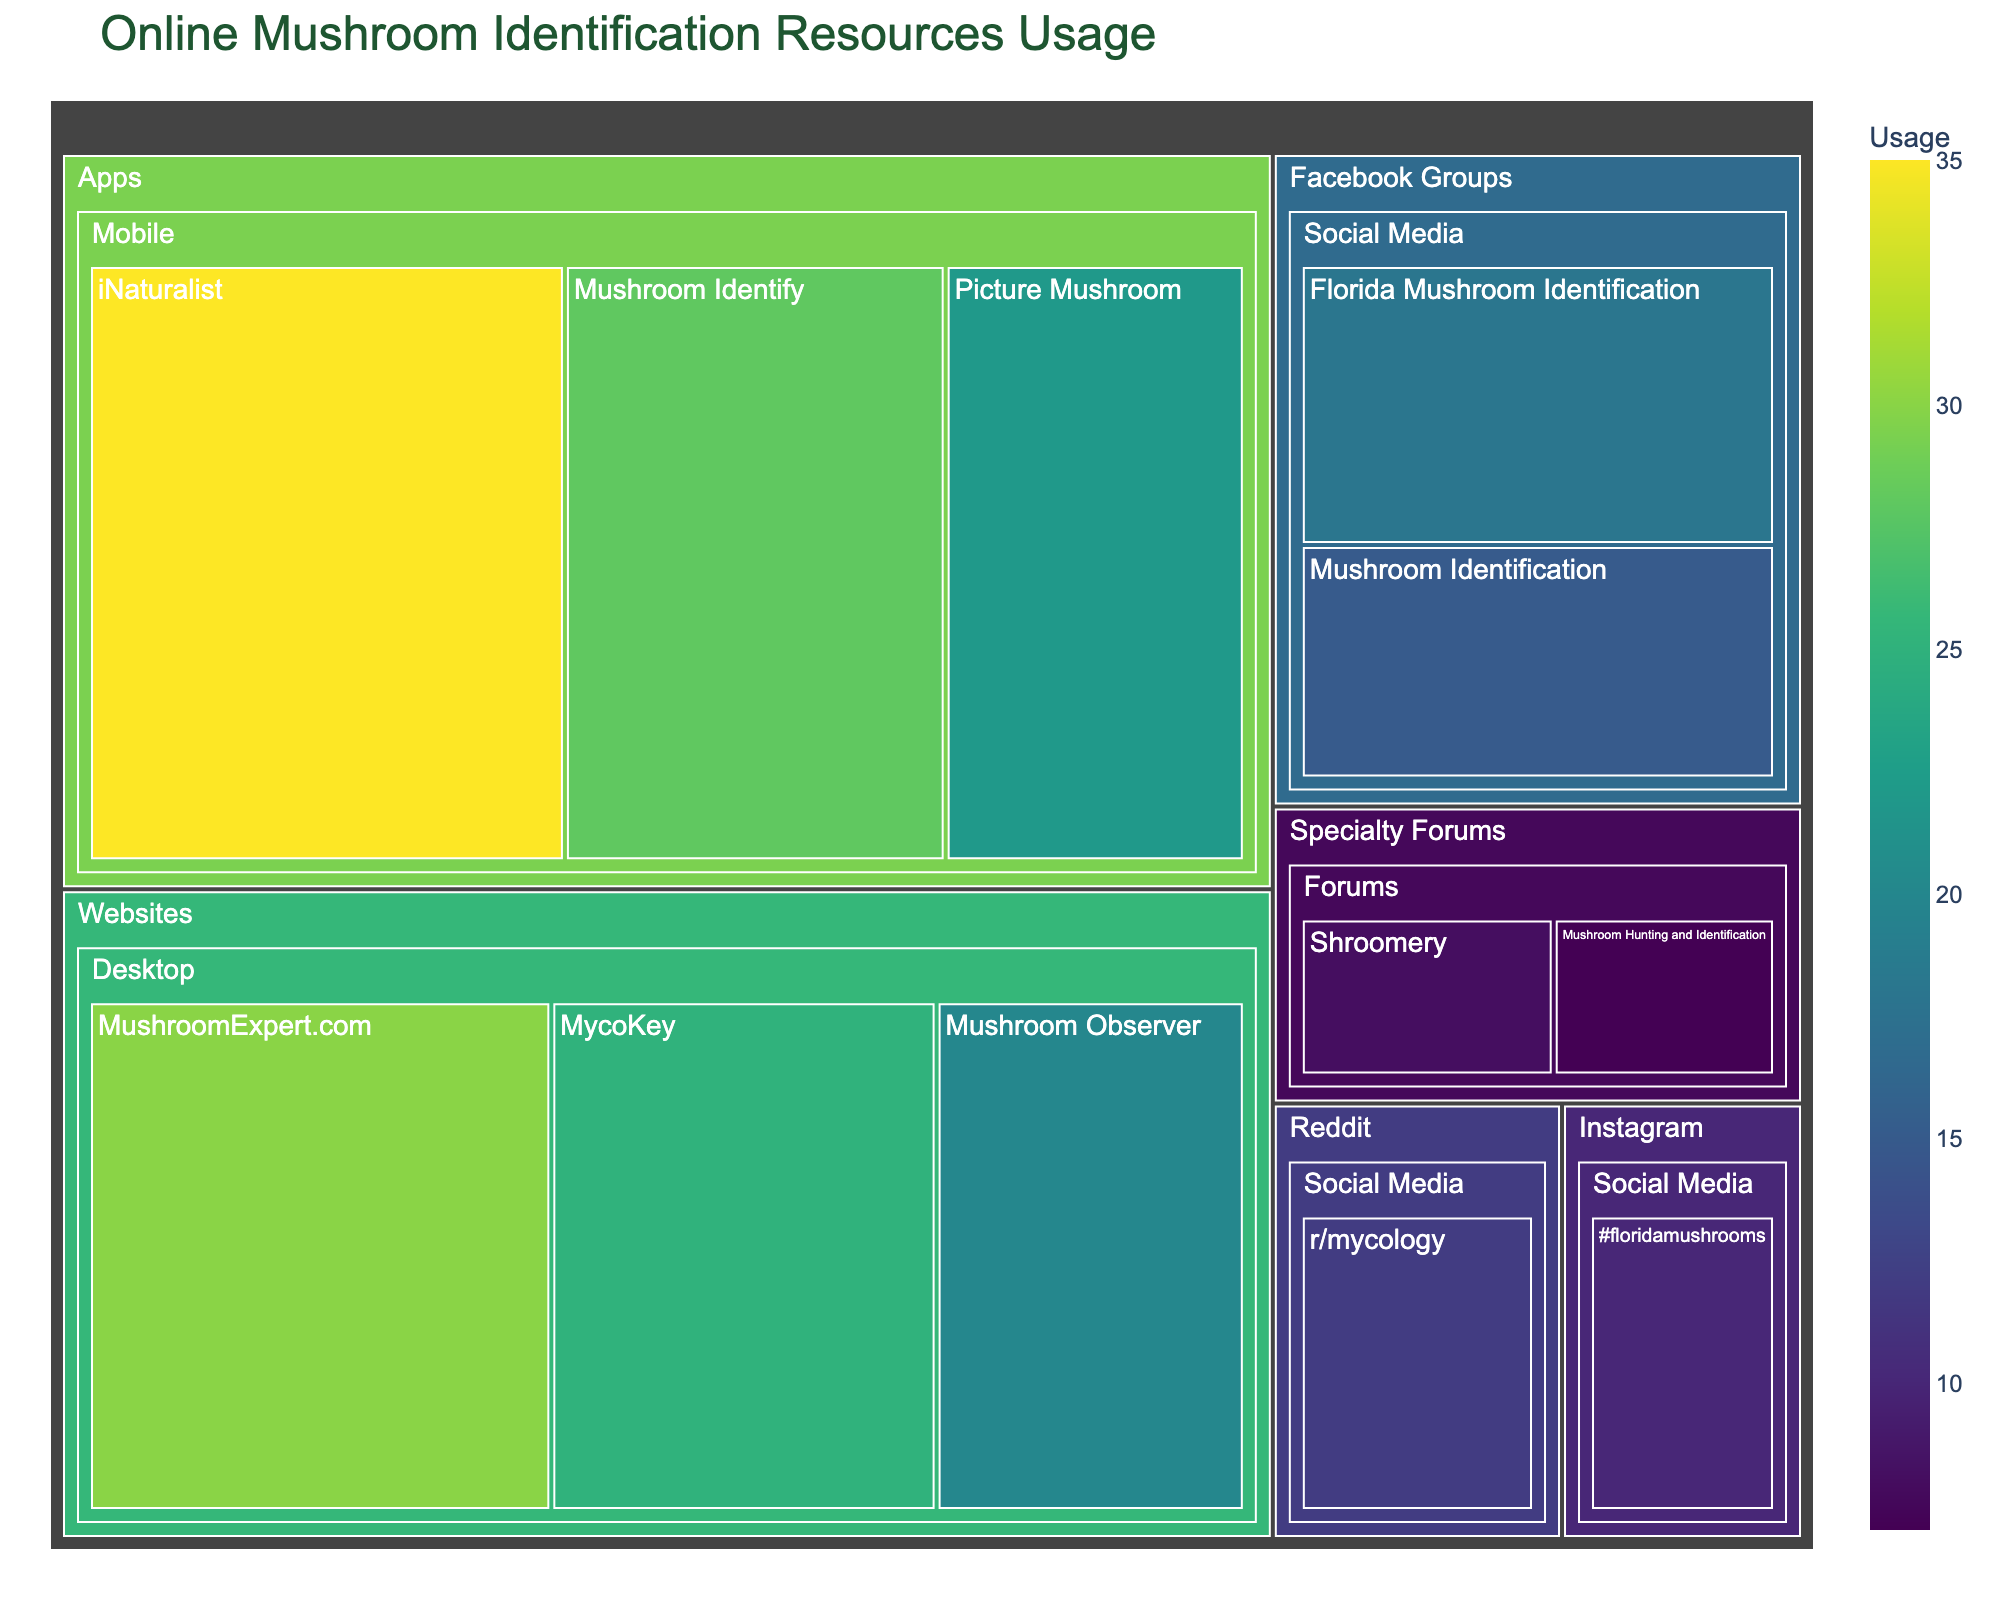What is the title of the treemap? The title of the plot is usually displayed at the top. It provides the main idea or context of what the plot represents.
Answer: Online Mushroom Identification Resources Usage Which category has the highest total usage? To determine this, visually assess each main category (Mobile, Desktop, Social Media, Forums) and sum up the usage values of the resources within each category. Mobile: (35 + 28 + 22) = 85, Desktop: (30 + 25 + 20) = 75, Social Media: (18 + 15 + 12 + 10) = 55, Forums: (8 + 7) = 15
Answer: Mobile What mobile app has the highest usage? Within the Mobile category, identify the app with the largest individual usage value.
Answer: iNaturalist Compare the total usage of Facebook Groups to Reddit and Instagram combined. Which is higher? Facebook Groups (18 + 15) = 33, Reddit and Instagram combined (12 + 10) = 22. Compare these totals.
Answer: Facebook Groups What are the two least used resources in the data? Examine all the resources listed and identify the ones with the smallest usage values.
Answer: Shroomery, Mushroom Hunting and Identification Which platform has the lowest total usage? Sum the total usage within each platform (Mobile, Desktop, Social Media, Forums) and find the smallest value. Mobile: 85, Desktop: 75, Social Media: 55, Forums: 15.
Answer: Forums What is the usage of "MushroomExpert.com"? Locate "MushroomExpert.com" under the Desktop category and identify its usage value.
Answer: 30 How does the usage of "Instagram (#floridamushrooms)" compare to "r/mycology" on Reddit? Identify the usage values for both resources and compare. Instagram: 10, Reddit: 12.
Answer: Instagram is lower Which web-based resource has the highest usage? Under the Desktop category, identify the resource with the highest individual usage value.
Answer: MushroomExpert.com What is the total usage of all the social media resources combined? Add up the usage values for all resources listed under the Social Media category: (18 + 15 + 12 + 10) = 55
Answer: 55 